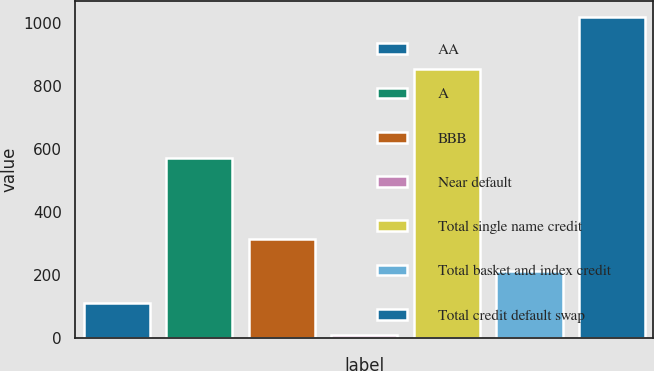Convert chart. <chart><loc_0><loc_0><loc_500><loc_500><bar_chart><fcel>AA<fcel>A<fcel>BBB<fcel>Near default<fcel>Total single name credit<fcel>Total basket and index credit<fcel>Total credit default swap<nl><fcel>111.84<fcel>572<fcel>313.32<fcel>11.1<fcel>853.1<fcel>212.58<fcel>1018.5<nl></chart> 